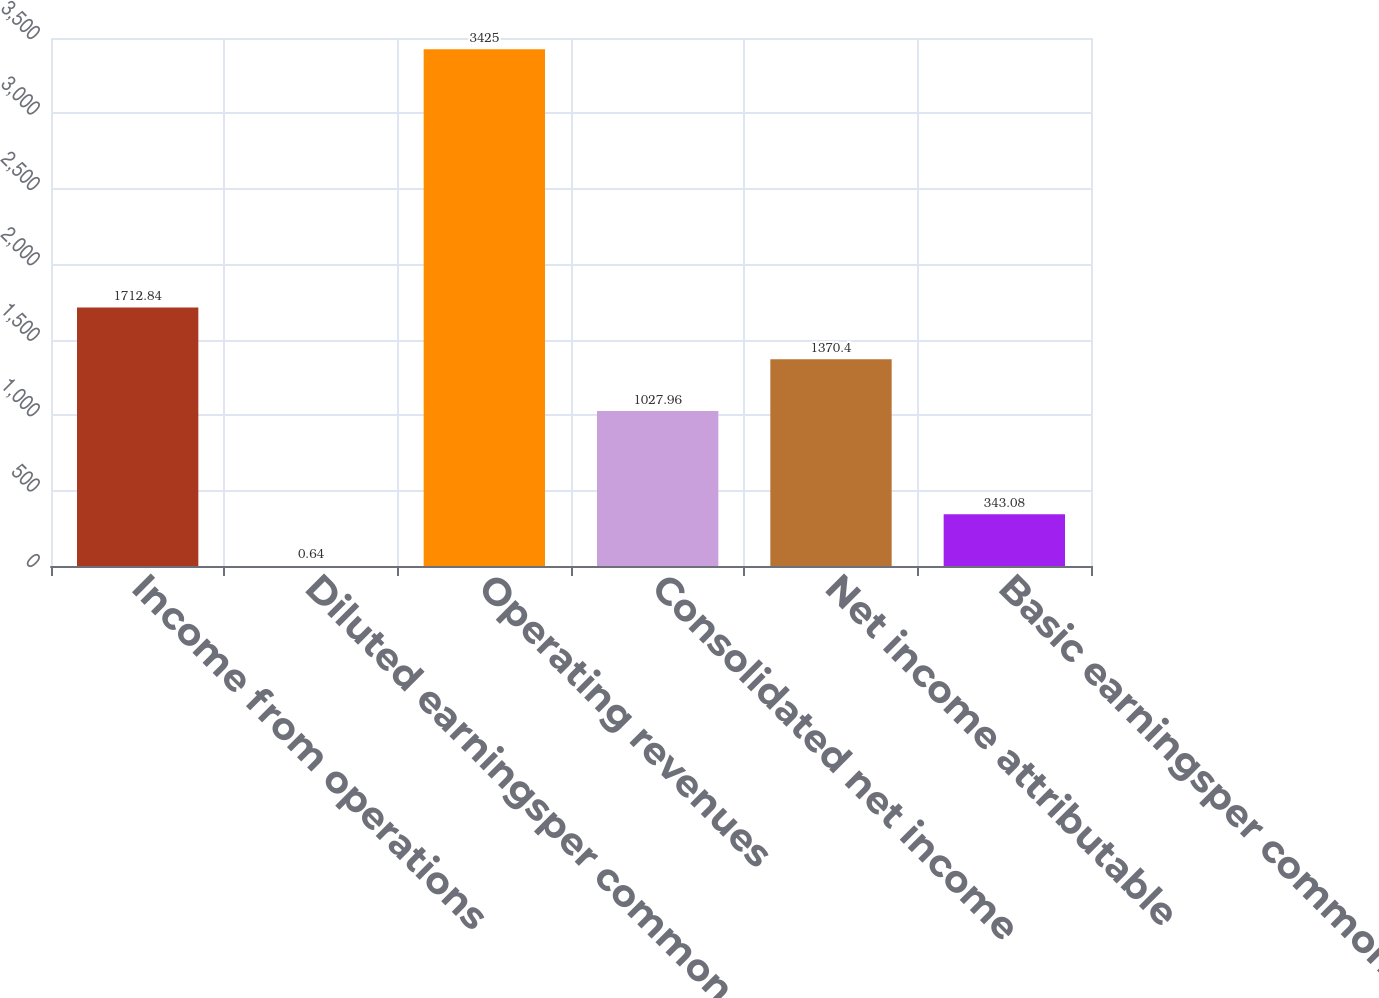Convert chart. <chart><loc_0><loc_0><loc_500><loc_500><bar_chart><fcel>Income from operations<fcel>Diluted earningsper common<fcel>Operating revenues<fcel>Consolidated net income<fcel>Net income attributable<fcel>Basic earningsper common share<nl><fcel>1712.84<fcel>0.64<fcel>3425<fcel>1027.96<fcel>1370.4<fcel>343.08<nl></chart> 